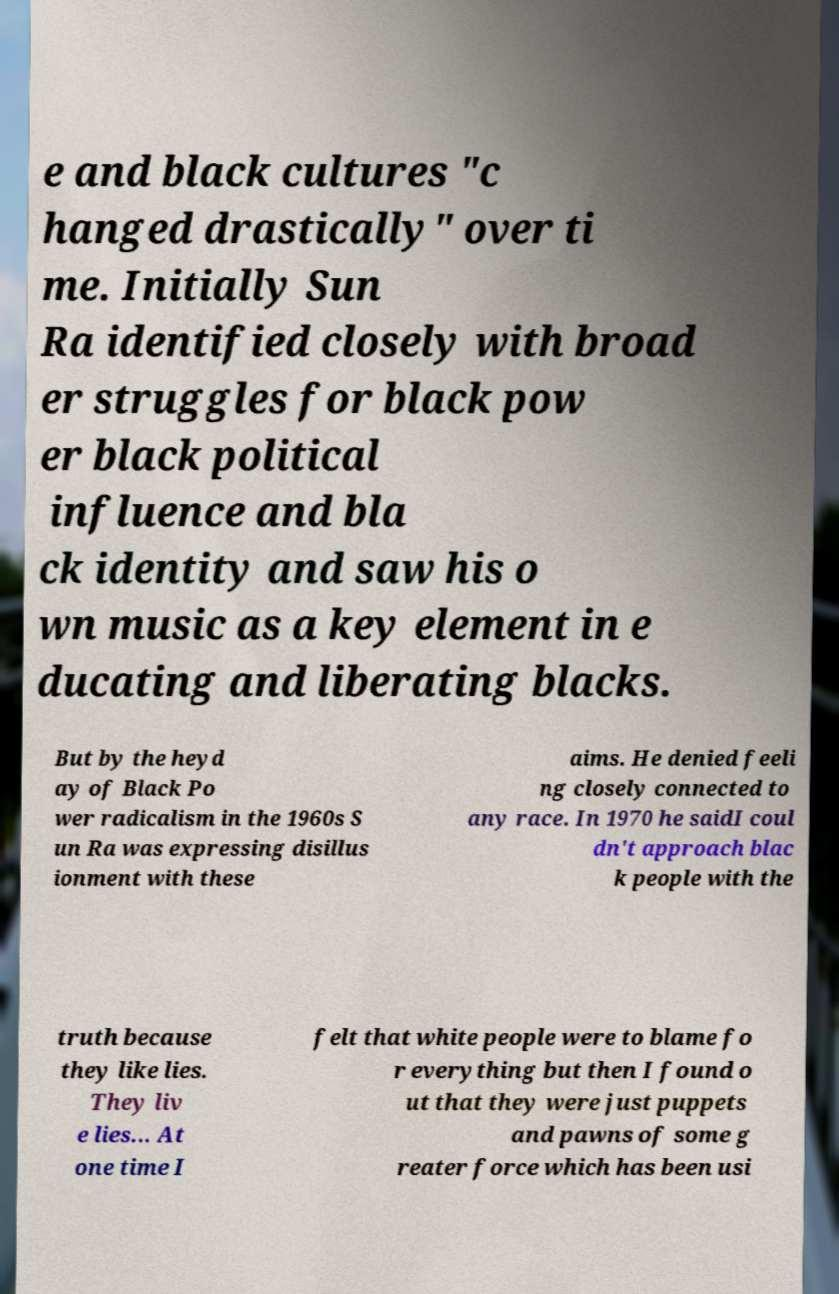I need the written content from this picture converted into text. Can you do that? e and black cultures "c hanged drastically" over ti me. Initially Sun Ra identified closely with broad er struggles for black pow er black political influence and bla ck identity and saw his o wn music as a key element in e ducating and liberating blacks. But by the heyd ay of Black Po wer radicalism in the 1960s S un Ra was expressing disillus ionment with these aims. He denied feeli ng closely connected to any race. In 1970 he saidI coul dn't approach blac k people with the truth because they like lies. They liv e lies... At one time I felt that white people were to blame fo r everything but then I found o ut that they were just puppets and pawns of some g reater force which has been usi 